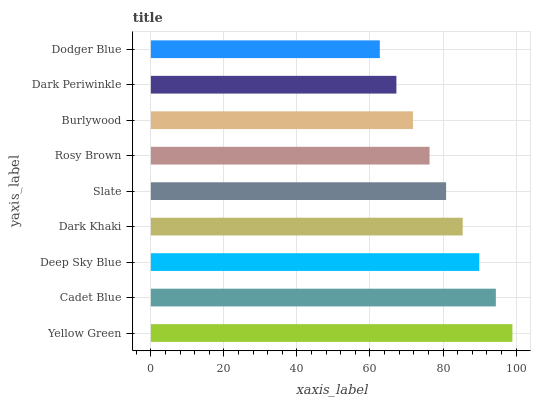Is Dodger Blue the minimum?
Answer yes or no. Yes. Is Yellow Green the maximum?
Answer yes or no. Yes. Is Cadet Blue the minimum?
Answer yes or no. No. Is Cadet Blue the maximum?
Answer yes or no. No. Is Yellow Green greater than Cadet Blue?
Answer yes or no. Yes. Is Cadet Blue less than Yellow Green?
Answer yes or no. Yes. Is Cadet Blue greater than Yellow Green?
Answer yes or no. No. Is Yellow Green less than Cadet Blue?
Answer yes or no. No. Is Slate the high median?
Answer yes or no. Yes. Is Slate the low median?
Answer yes or no. Yes. Is Yellow Green the high median?
Answer yes or no. No. Is Dark Khaki the low median?
Answer yes or no. No. 